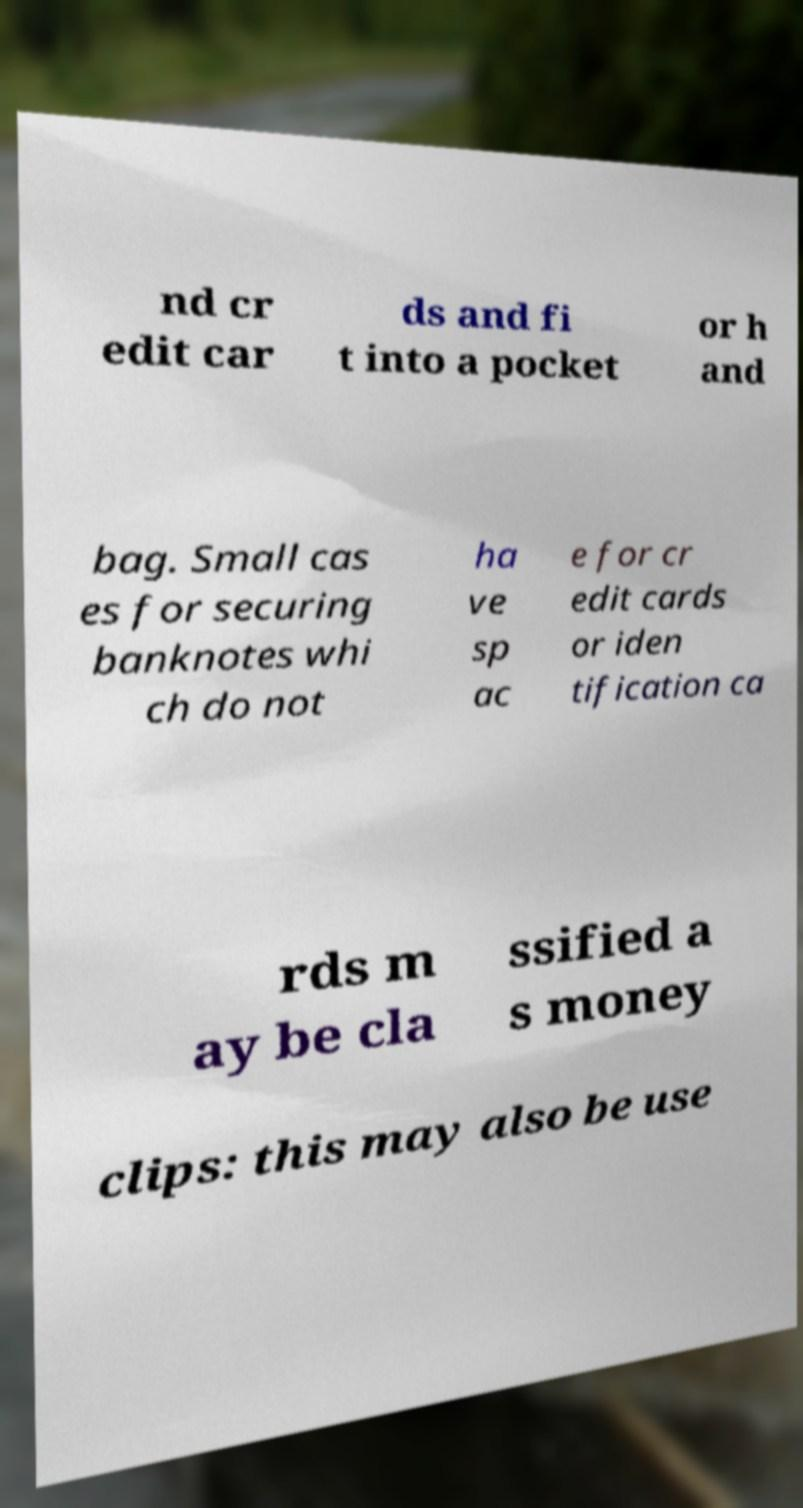Can you accurately transcribe the text from the provided image for me? nd cr edit car ds and fi t into a pocket or h and bag. Small cas es for securing banknotes whi ch do not ha ve sp ac e for cr edit cards or iden tification ca rds m ay be cla ssified a s money clips: this may also be use 